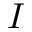<formula> <loc_0><loc_0><loc_500><loc_500>I</formula> 